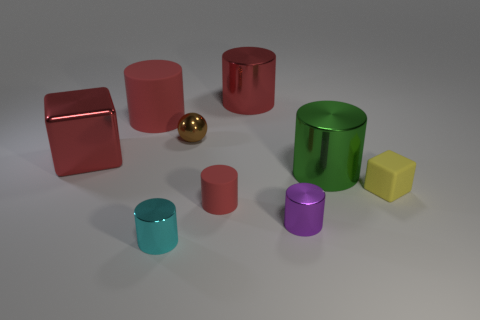Subtract all blue spheres. How many red cylinders are left? 3 Subtract all cyan cylinders. How many cylinders are left? 5 Subtract all green cylinders. How many cylinders are left? 5 Subtract all green cylinders. Subtract all green blocks. How many cylinders are left? 5 Add 1 small purple spheres. How many objects exist? 10 Subtract all balls. How many objects are left? 8 Subtract 0 yellow balls. How many objects are left? 9 Subtract all big red matte cylinders. Subtract all cylinders. How many objects are left? 2 Add 2 small yellow rubber things. How many small yellow rubber things are left? 3 Add 9 green cylinders. How many green cylinders exist? 10 